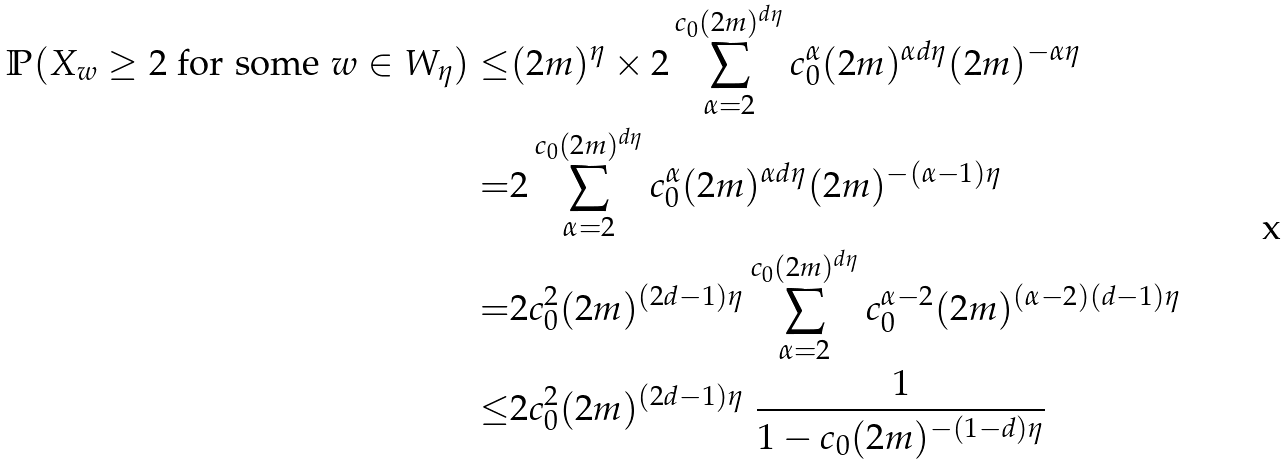Convert formula to latex. <formula><loc_0><loc_0><loc_500><loc_500>\mathbb { P } ( X _ { w } \geq 2 \text { for some } w \in W _ { \eta } ) \leq & ( 2 m ) ^ { \eta } \times 2 \sum _ { \alpha = 2 } ^ { c _ { 0 } ( 2 m ) ^ { d \eta } } c _ { 0 } ^ { \alpha } ( 2 m ) ^ { \alpha d \eta } ( 2 m ) ^ { - \alpha \eta } \\ = & 2 \sum _ { \alpha = 2 } ^ { c _ { 0 } ( 2 m ) ^ { d \eta } } c _ { 0 } ^ { \alpha } ( 2 m ) ^ { \alpha d \eta } ( 2 m ) ^ { - ( \alpha - 1 ) \eta } \\ = & 2 c _ { 0 } ^ { 2 } ( 2 m ) ^ { ( 2 d - 1 ) \eta } \sum _ { \alpha = 2 } ^ { c _ { 0 } ( 2 m ) ^ { d \eta } } c _ { 0 } ^ { \alpha - 2 } ( 2 m ) ^ { ( \alpha - 2 ) ( d - 1 ) \eta } \\ \leq & 2 c _ { 0 } ^ { 2 } ( 2 m ) ^ { ( 2 d - 1 ) \eta } \ \frac { 1 } { 1 - c _ { 0 } ( 2 m ) ^ { - ( 1 - d ) \eta } }</formula> 